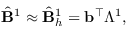Convert formula to latex. <formula><loc_0><loc_0><loc_500><loc_500>\begin{array} { r } { \hat { B } ^ { 1 } \approx \hat { B } _ { h } ^ { 1 } = b ^ { \top } \mathbb { \Lambda } ^ { 1 } , } \end{array}</formula> 